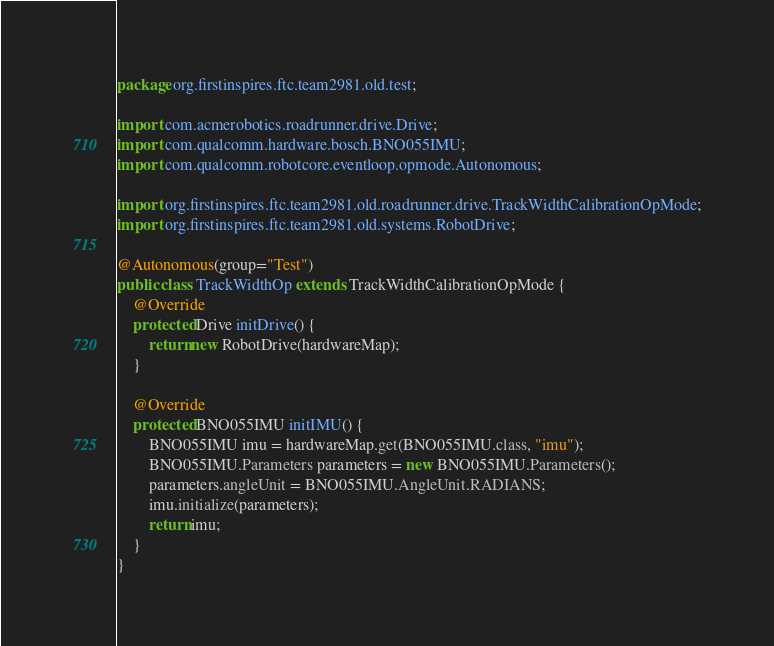Convert code to text. <code><loc_0><loc_0><loc_500><loc_500><_Java_>package org.firstinspires.ftc.team2981.old.test;

import com.acmerobotics.roadrunner.drive.Drive;
import com.qualcomm.hardware.bosch.BNO055IMU;
import com.qualcomm.robotcore.eventloop.opmode.Autonomous;

import org.firstinspires.ftc.team2981.old.roadrunner.drive.TrackWidthCalibrationOpMode;
import org.firstinspires.ftc.team2981.old.systems.RobotDrive;

@Autonomous(group="Test")
public class TrackWidthOp extends TrackWidthCalibrationOpMode {
    @Override
    protected Drive initDrive() {
        return new RobotDrive(hardwareMap);
    }

    @Override
    protected BNO055IMU initIMU() {
        BNO055IMU imu = hardwareMap.get(BNO055IMU.class, "imu");
        BNO055IMU.Parameters parameters = new BNO055IMU.Parameters();
        parameters.angleUnit = BNO055IMU.AngleUnit.RADIANS;
        imu.initialize(parameters);
        return imu;
    }
}
</code> 